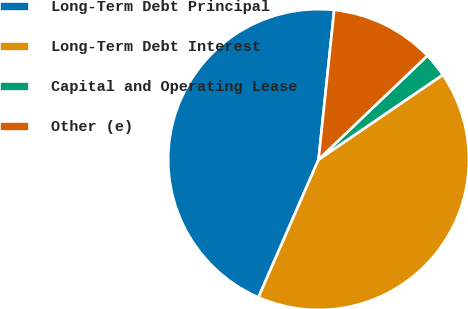Convert chart to OTSL. <chart><loc_0><loc_0><loc_500><loc_500><pie_chart><fcel>Long-Term Debt Principal<fcel>Long-Term Debt Interest<fcel>Capital and Operating Lease<fcel>Other (e)<nl><fcel>45.11%<fcel>41.07%<fcel>2.6%<fcel>11.21%<nl></chart> 